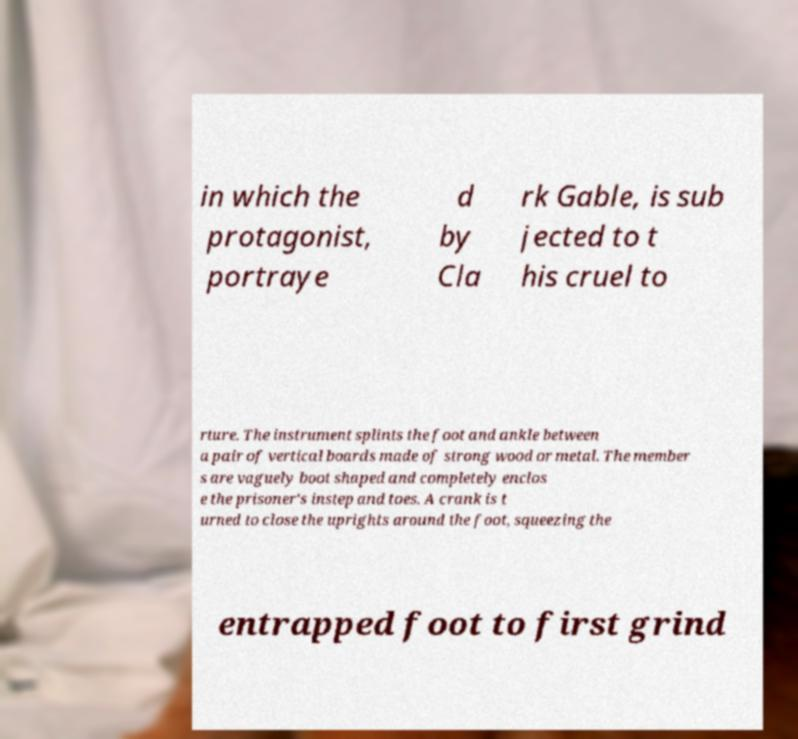I need the written content from this picture converted into text. Can you do that? in which the protagonist, portraye d by Cla rk Gable, is sub jected to t his cruel to rture. The instrument splints the foot and ankle between a pair of vertical boards made of strong wood or metal. The member s are vaguely boot shaped and completely enclos e the prisoner's instep and toes. A crank is t urned to close the uprights around the foot, squeezing the entrapped foot to first grind 